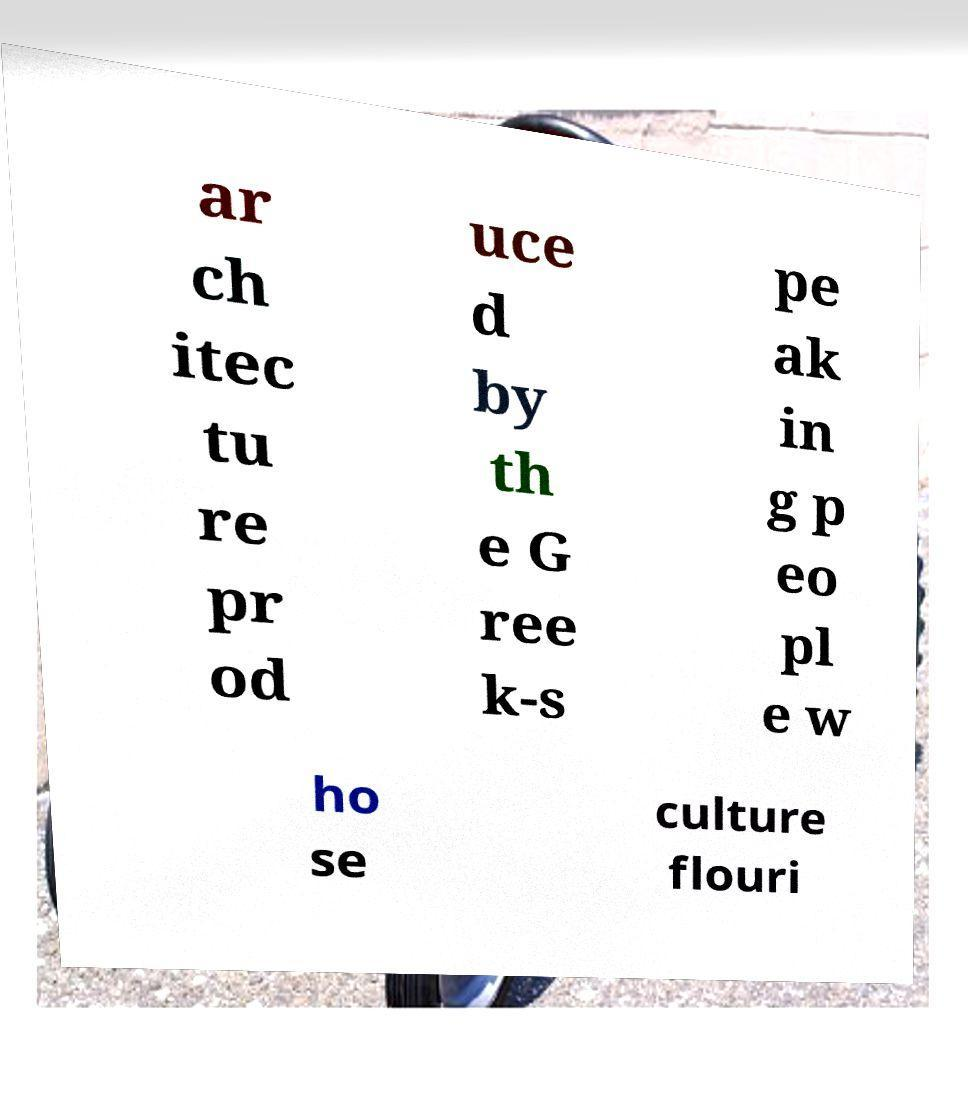What messages or text are displayed in this image? I need them in a readable, typed format. ar ch itec tu re pr od uce d by th e G ree k-s pe ak in g p eo pl e w ho se culture flouri 